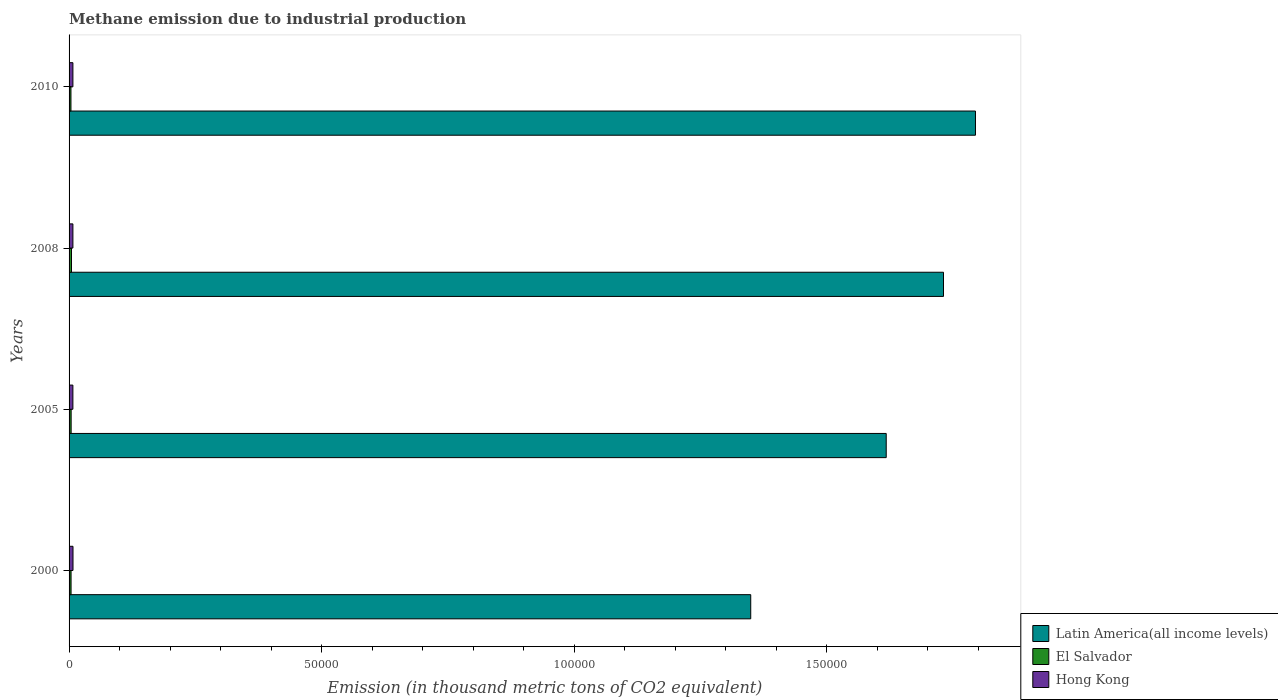How many different coloured bars are there?
Your response must be concise. 3. How many groups of bars are there?
Give a very brief answer. 4. Are the number of bars per tick equal to the number of legend labels?
Your answer should be compact. Yes. How many bars are there on the 1st tick from the top?
Provide a short and direct response. 3. What is the amount of methane emitted in Latin America(all income levels) in 2008?
Offer a terse response. 1.73e+05. Across all years, what is the maximum amount of methane emitted in El Salvador?
Your response must be concise. 477.6. Across all years, what is the minimum amount of methane emitted in Hong Kong?
Make the answer very short. 756.9. In which year was the amount of methane emitted in Latin America(all income levels) minimum?
Provide a short and direct response. 2000. What is the total amount of methane emitted in Latin America(all income levels) in the graph?
Make the answer very short. 6.49e+05. What is the difference between the amount of methane emitted in Latin America(all income levels) in 2000 and that in 2005?
Offer a very short reply. -2.68e+04. What is the difference between the amount of methane emitted in Hong Kong in 2010 and the amount of methane emitted in El Salvador in 2008?
Ensure brevity in your answer.  282.3. What is the average amount of methane emitted in El Salvador per year?
Your answer should be compact. 413.27. In the year 2010, what is the difference between the amount of methane emitted in El Salvador and amount of methane emitted in Latin America(all income levels)?
Offer a terse response. -1.79e+05. What is the ratio of the amount of methane emitted in Latin America(all income levels) in 2008 to that in 2010?
Make the answer very short. 0.96. What is the difference between the highest and the second highest amount of methane emitted in Latin America(all income levels)?
Ensure brevity in your answer.  6327. What is the difference between the highest and the lowest amount of methane emitted in Hong Kong?
Make the answer very short. 21.5. In how many years, is the amount of methane emitted in Hong Kong greater than the average amount of methane emitted in Hong Kong taken over all years?
Offer a terse response. 1. Is the sum of the amount of methane emitted in Hong Kong in 2005 and 2008 greater than the maximum amount of methane emitted in Latin America(all income levels) across all years?
Provide a short and direct response. No. What does the 1st bar from the top in 2000 represents?
Make the answer very short. Hong Kong. What does the 2nd bar from the bottom in 2010 represents?
Offer a terse response. El Salvador. How many bars are there?
Ensure brevity in your answer.  12. Are all the bars in the graph horizontal?
Make the answer very short. Yes. How many years are there in the graph?
Keep it short and to the point. 4. What is the difference between two consecutive major ticks on the X-axis?
Provide a short and direct response. 5.00e+04. Where does the legend appear in the graph?
Offer a terse response. Bottom right. How are the legend labels stacked?
Give a very brief answer. Vertical. What is the title of the graph?
Your answer should be very brief. Methane emission due to industrial production. Does "Arab World" appear as one of the legend labels in the graph?
Your response must be concise. No. What is the label or title of the X-axis?
Ensure brevity in your answer.  Emission (in thousand metric tons of CO2 equivalent). What is the Emission (in thousand metric tons of CO2 equivalent) in Latin America(all income levels) in 2000?
Your response must be concise. 1.35e+05. What is the Emission (in thousand metric tons of CO2 equivalent) in El Salvador in 2000?
Your response must be concise. 393.6. What is the Emission (in thousand metric tons of CO2 equivalent) in Hong Kong in 2000?
Provide a succinct answer. 778.4. What is the Emission (in thousand metric tons of CO2 equivalent) in Latin America(all income levels) in 2005?
Give a very brief answer. 1.62e+05. What is the Emission (in thousand metric tons of CO2 equivalent) in El Salvador in 2005?
Your answer should be compact. 409.3. What is the Emission (in thousand metric tons of CO2 equivalent) of Hong Kong in 2005?
Make the answer very short. 756.9. What is the Emission (in thousand metric tons of CO2 equivalent) of Latin America(all income levels) in 2008?
Provide a short and direct response. 1.73e+05. What is the Emission (in thousand metric tons of CO2 equivalent) of El Salvador in 2008?
Your answer should be compact. 477.6. What is the Emission (in thousand metric tons of CO2 equivalent) of Hong Kong in 2008?
Offer a very short reply. 760.6. What is the Emission (in thousand metric tons of CO2 equivalent) of Latin America(all income levels) in 2010?
Your answer should be very brief. 1.79e+05. What is the Emission (in thousand metric tons of CO2 equivalent) of El Salvador in 2010?
Your answer should be very brief. 372.6. What is the Emission (in thousand metric tons of CO2 equivalent) in Hong Kong in 2010?
Make the answer very short. 759.9. Across all years, what is the maximum Emission (in thousand metric tons of CO2 equivalent) in Latin America(all income levels)?
Keep it short and to the point. 1.79e+05. Across all years, what is the maximum Emission (in thousand metric tons of CO2 equivalent) in El Salvador?
Your answer should be compact. 477.6. Across all years, what is the maximum Emission (in thousand metric tons of CO2 equivalent) in Hong Kong?
Keep it short and to the point. 778.4. Across all years, what is the minimum Emission (in thousand metric tons of CO2 equivalent) of Latin America(all income levels)?
Your answer should be very brief. 1.35e+05. Across all years, what is the minimum Emission (in thousand metric tons of CO2 equivalent) in El Salvador?
Give a very brief answer. 372.6. Across all years, what is the minimum Emission (in thousand metric tons of CO2 equivalent) in Hong Kong?
Ensure brevity in your answer.  756.9. What is the total Emission (in thousand metric tons of CO2 equivalent) in Latin America(all income levels) in the graph?
Provide a short and direct response. 6.49e+05. What is the total Emission (in thousand metric tons of CO2 equivalent) of El Salvador in the graph?
Offer a terse response. 1653.1. What is the total Emission (in thousand metric tons of CO2 equivalent) in Hong Kong in the graph?
Give a very brief answer. 3055.8. What is the difference between the Emission (in thousand metric tons of CO2 equivalent) of Latin America(all income levels) in 2000 and that in 2005?
Offer a terse response. -2.68e+04. What is the difference between the Emission (in thousand metric tons of CO2 equivalent) in El Salvador in 2000 and that in 2005?
Your answer should be very brief. -15.7. What is the difference between the Emission (in thousand metric tons of CO2 equivalent) in Hong Kong in 2000 and that in 2005?
Give a very brief answer. 21.5. What is the difference between the Emission (in thousand metric tons of CO2 equivalent) in Latin America(all income levels) in 2000 and that in 2008?
Provide a short and direct response. -3.82e+04. What is the difference between the Emission (in thousand metric tons of CO2 equivalent) in El Salvador in 2000 and that in 2008?
Offer a terse response. -84. What is the difference between the Emission (in thousand metric tons of CO2 equivalent) of Hong Kong in 2000 and that in 2008?
Your answer should be compact. 17.8. What is the difference between the Emission (in thousand metric tons of CO2 equivalent) of Latin America(all income levels) in 2000 and that in 2010?
Offer a terse response. -4.45e+04. What is the difference between the Emission (in thousand metric tons of CO2 equivalent) of El Salvador in 2000 and that in 2010?
Ensure brevity in your answer.  21. What is the difference between the Emission (in thousand metric tons of CO2 equivalent) in Hong Kong in 2000 and that in 2010?
Offer a very short reply. 18.5. What is the difference between the Emission (in thousand metric tons of CO2 equivalent) in Latin America(all income levels) in 2005 and that in 2008?
Your response must be concise. -1.13e+04. What is the difference between the Emission (in thousand metric tons of CO2 equivalent) of El Salvador in 2005 and that in 2008?
Your answer should be compact. -68.3. What is the difference between the Emission (in thousand metric tons of CO2 equivalent) of Latin America(all income levels) in 2005 and that in 2010?
Give a very brief answer. -1.77e+04. What is the difference between the Emission (in thousand metric tons of CO2 equivalent) in El Salvador in 2005 and that in 2010?
Ensure brevity in your answer.  36.7. What is the difference between the Emission (in thousand metric tons of CO2 equivalent) of Hong Kong in 2005 and that in 2010?
Offer a very short reply. -3. What is the difference between the Emission (in thousand metric tons of CO2 equivalent) in Latin America(all income levels) in 2008 and that in 2010?
Your response must be concise. -6327. What is the difference between the Emission (in thousand metric tons of CO2 equivalent) in El Salvador in 2008 and that in 2010?
Your answer should be compact. 105. What is the difference between the Emission (in thousand metric tons of CO2 equivalent) of Latin America(all income levels) in 2000 and the Emission (in thousand metric tons of CO2 equivalent) of El Salvador in 2005?
Your response must be concise. 1.35e+05. What is the difference between the Emission (in thousand metric tons of CO2 equivalent) in Latin America(all income levels) in 2000 and the Emission (in thousand metric tons of CO2 equivalent) in Hong Kong in 2005?
Your response must be concise. 1.34e+05. What is the difference between the Emission (in thousand metric tons of CO2 equivalent) of El Salvador in 2000 and the Emission (in thousand metric tons of CO2 equivalent) of Hong Kong in 2005?
Keep it short and to the point. -363.3. What is the difference between the Emission (in thousand metric tons of CO2 equivalent) of Latin America(all income levels) in 2000 and the Emission (in thousand metric tons of CO2 equivalent) of El Salvador in 2008?
Offer a terse response. 1.34e+05. What is the difference between the Emission (in thousand metric tons of CO2 equivalent) in Latin America(all income levels) in 2000 and the Emission (in thousand metric tons of CO2 equivalent) in Hong Kong in 2008?
Provide a succinct answer. 1.34e+05. What is the difference between the Emission (in thousand metric tons of CO2 equivalent) in El Salvador in 2000 and the Emission (in thousand metric tons of CO2 equivalent) in Hong Kong in 2008?
Provide a succinct answer. -367. What is the difference between the Emission (in thousand metric tons of CO2 equivalent) in Latin America(all income levels) in 2000 and the Emission (in thousand metric tons of CO2 equivalent) in El Salvador in 2010?
Make the answer very short. 1.35e+05. What is the difference between the Emission (in thousand metric tons of CO2 equivalent) of Latin America(all income levels) in 2000 and the Emission (in thousand metric tons of CO2 equivalent) of Hong Kong in 2010?
Keep it short and to the point. 1.34e+05. What is the difference between the Emission (in thousand metric tons of CO2 equivalent) in El Salvador in 2000 and the Emission (in thousand metric tons of CO2 equivalent) in Hong Kong in 2010?
Your answer should be compact. -366.3. What is the difference between the Emission (in thousand metric tons of CO2 equivalent) of Latin America(all income levels) in 2005 and the Emission (in thousand metric tons of CO2 equivalent) of El Salvador in 2008?
Your response must be concise. 1.61e+05. What is the difference between the Emission (in thousand metric tons of CO2 equivalent) of Latin America(all income levels) in 2005 and the Emission (in thousand metric tons of CO2 equivalent) of Hong Kong in 2008?
Your answer should be very brief. 1.61e+05. What is the difference between the Emission (in thousand metric tons of CO2 equivalent) of El Salvador in 2005 and the Emission (in thousand metric tons of CO2 equivalent) of Hong Kong in 2008?
Offer a terse response. -351.3. What is the difference between the Emission (in thousand metric tons of CO2 equivalent) of Latin America(all income levels) in 2005 and the Emission (in thousand metric tons of CO2 equivalent) of El Salvador in 2010?
Keep it short and to the point. 1.61e+05. What is the difference between the Emission (in thousand metric tons of CO2 equivalent) of Latin America(all income levels) in 2005 and the Emission (in thousand metric tons of CO2 equivalent) of Hong Kong in 2010?
Offer a very short reply. 1.61e+05. What is the difference between the Emission (in thousand metric tons of CO2 equivalent) in El Salvador in 2005 and the Emission (in thousand metric tons of CO2 equivalent) in Hong Kong in 2010?
Provide a succinct answer. -350.6. What is the difference between the Emission (in thousand metric tons of CO2 equivalent) in Latin America(all income levels) in 2008 and the Emission (in thousand metric tons of CO2 equivalent) in El Salvador in 2010?
Offer a very short reply. 1.73e+05. What is the difference between the Emission (in thousand metric tons of CO2 equivalent) in Latin America(all income levels) in 2008 and the Emission (in thousand metric tons of CO2 equivalent) in Hong Kong in 2010?
Offer a very short reply. 1.72e+05. What is the difference between the Emission (in thousand metric tons of CO2 equivalent) in El Salvador in 2008 and the Emission (in thousand metric tons of CO2 equivalent) in Hong Kong in 2010?
Give a very brief answer. -282.3. What is the average Emission (in thousand metric tons of CO2 equivalent) of Latin America(all income levels) per year?
Your answer should be very brief. 1.62e+05. What is the average Emission (in thousand metric tons of CO2 equivalent) in El Salvador per year?
Your answer should be compact. 413.27. What is the average Emission (in thousand metric tons of CO2 equivalent) in Hong Kong per year?
Your answer should be compact. 763.95. In the year 2000, what is the difference between the Emission (in thousand metric tons of CO2 equivalent) in Latin America(all income levels) and Emission (in thousand metric tons of CO2 equivalent) in El Salvador?
Provide a succinct answer. 1.35e+05. In the year 2000, what is the difference between the Emission (in thousand metric tons of CO2 equivalent) in Latin America(all income levels) and Emission (in thousand metric tons of CO2 equivalent) in Hong Kong?
Offer a very short reply. 1.34e+05. In the year 2000, what is the difference between the Emission (in thousand metric tons of CO2 equivalent) in El Salvador and Emission (in thousand metric tons of CO2 equivalent) in Hong Kong?
Your answer should be compact. -384.8. In the year 2005, what is the difference between the Emission (in thousand metric tons of CO2 equivalent) of Latin America(all income levels) and Emission (in thousand metric tons of CO2 equivalent) of El Salvador?
Your answer should be compact. 1.61e+05. In the year 2005, what is the difference between the Emission (in thousand metric tons of CO2 equivalent) in Latin America(all income levels) and Emission (in thousand metric tons of CO2 equivalent) in Hong Kong?
Offer a terse response. 1.61e+05. In the year 2005, what is the difference between the Emission (in thousand metric tons of CO2 equivalent) in El Salvador and Emission (in thousand metric tons of CO2 equivalent) in Hong Kong?
Your response must be concise. -347.6. In the year 2008, what is the difference between the Emission (in thousand metric tons of CO2 equivalent) of Latin America(all income levels) and Emission (in thousand metric tons of CO2 equivalent) of El Salvador?
Your response must be concise. 1.73e+05. In the year 2008, what is the difference between the Emission (in thousand metric tons of CO2 equivalent) of Latin America(all income levels) and Emission (in thousand metric tons of CO2 equivalent) of Hong Kong?
Make the answer very short. 1.72e+05. In the year 2008, what is the difference between the Emission (in thousand metric tons of CO2 equivalent) of El Salvador and Emission (in thousand metric tons of CO2 equivalent) of Hong Kong?
Your answer should be very brief. -283. In the year 2010, what is the difference between the Emission (in thousand metric tons of CO2 equivalent) in Latin America(all income levels) and Emission (in thousand metric tons of CO2 equivalent) in El Salvador?
Keep it short and to the point. 1.79e+05. In the year 2010, what is the difference between the Emission (in thousand metric tons of CO2 equivalent) of Latin America(all income levels) and Emission (in thousand metric tons of CO2 equivalent) of Hong Kong?
Your response must be concise. 1.79e+05. In the year 2010, what is the difference between the Emission (in thousand metric tons of CO2 equivalent) of El Salvador and Emission (in thousand metric tons of CO2 equivalent) of Hong Kong?
Your response must be concise. -387.3. What is the ratio of the Emission (in thousand metric tons of CO2 equivalent) in Latin America(all income levels) in 2000 to that in 2005?
Ensure brevity in your answer.  0.83. What is the ratio of the Emission (in thousand metric tons of CO2 equivalent) of El Salvador in 2000 to that in 2005?
Keep it short and to the point. 0.96. What is the ratio of the Emission (in thousand metric tons of CO2 equivalent) of Hong Kong in 2000 to that in 2005?
Keep it short and to the point. 1.03. What is the ratio of the Emission (in thousand metric tons of CO2 equivalent) of Latin America(all income levels) in 2000 to that in 2008?
Ensure brevity in your answer.  0.78. What is the ratio of the Emission (in thousand metric tons of CO2 equivalent) of El Salvador in 2000 to that in 2008?
Provide a short and direct response. 0.82. What is the ratio of the Emission (in thousand metric tons of CO2 equivalent) in Hong Kong in 2000 to that in 2008?
Provide a short and direct response. 1.02. What is the ratio of the Emission (in thousand metric tons of CO2 equivalent) in Latin America(all income levels) in 2000 to that in 2010?
Make the answer very short. 0.75. What is the ratio of the Emission (in thousand metric tons of CO2 equivalent) in El Salvador in 2000 to that in 2010?
Offer a terse response. 1.06. What is the ratio of the Emission (in thousand metric tons of CO2 equivalent) in Hong Kong in 2000 to that in 2010?
Your answer should be very brief. 1.02. What is the ratio of the Emission (in thousand metric tons of CO2 equivalent) of Latin America(all income levels) in 2005 to that in 2008?
Make the answer very short. 0.93. What is the ratio of the Emission (in thousand metric tons of CO2 equivalent) of El Salvador in 2005 to that in 2008?
Offer a terse response. 0.86. What is the ratio of the Emission (in thousand metric tons of CO2 equivalent) in Hong Kong in 2005 to that in 2008?
Provide a succinct answer. 1. What is the ratio of the Emission (in thousand metric tons of CO2 equivalent) of Latin America(all income levels) in 2005 to that in 2010?
Give a very brief answer. 0.9. What is the ratio of the Emission (in thousand metric tons of CO2 equivalent) of El Salvador in 2005 to that in 2010?
Your answer should be very brief. 1.1. What is the ratio of the Emission (in thousand metric tons of CO2 equivalent) in Hong Kong in 2005 to that in 2010?
Offer a terse response. 1. What is the ratio of the Emission (in thousand metric tons of CO2 equivalent) in Latin America(all income levels) in 2008 to that in 2010?
Provide a succinct answer. 0.96. What is the ratio of the Emission (in thousand metric tons of CO2 equivalent) in El Salvador in 2008 to that in 2010?
Offer a very short reply. 1.28. What is the ratio of the Emission (in thousand metric tons of CO2 equivalent) in Hong Kong in 2008 to that in 2010?
Give a very brief answer. 1. What is the difference between the highest and the second highest Emission (in thousand metric tons of CO2 equivalent) of Latin America(all income levels)?
Offer a very short reply. 6327. What is the difference between the highest and the second highest Emission (in thousand metric tons of CO2 equivalent) in El Salvador?
Make the answer very short. 68.3. What is the difference between the highest and the lowest Emission (in thousand metric tons of CO2 equivalent) in Latin America(all income levels)?
Your response must be concise. 4.45e+04. What is the difference between the highest and the lowest Emission (in thousand metric tons of CO2 equivalent) in El Salvador?
Offer a terse response. 105. What is the difference between the highest and the lowest Emission (in thousand metric tons of CO2 equivalent) of Hong Kong?
Give a very brief answer. 21.5. 